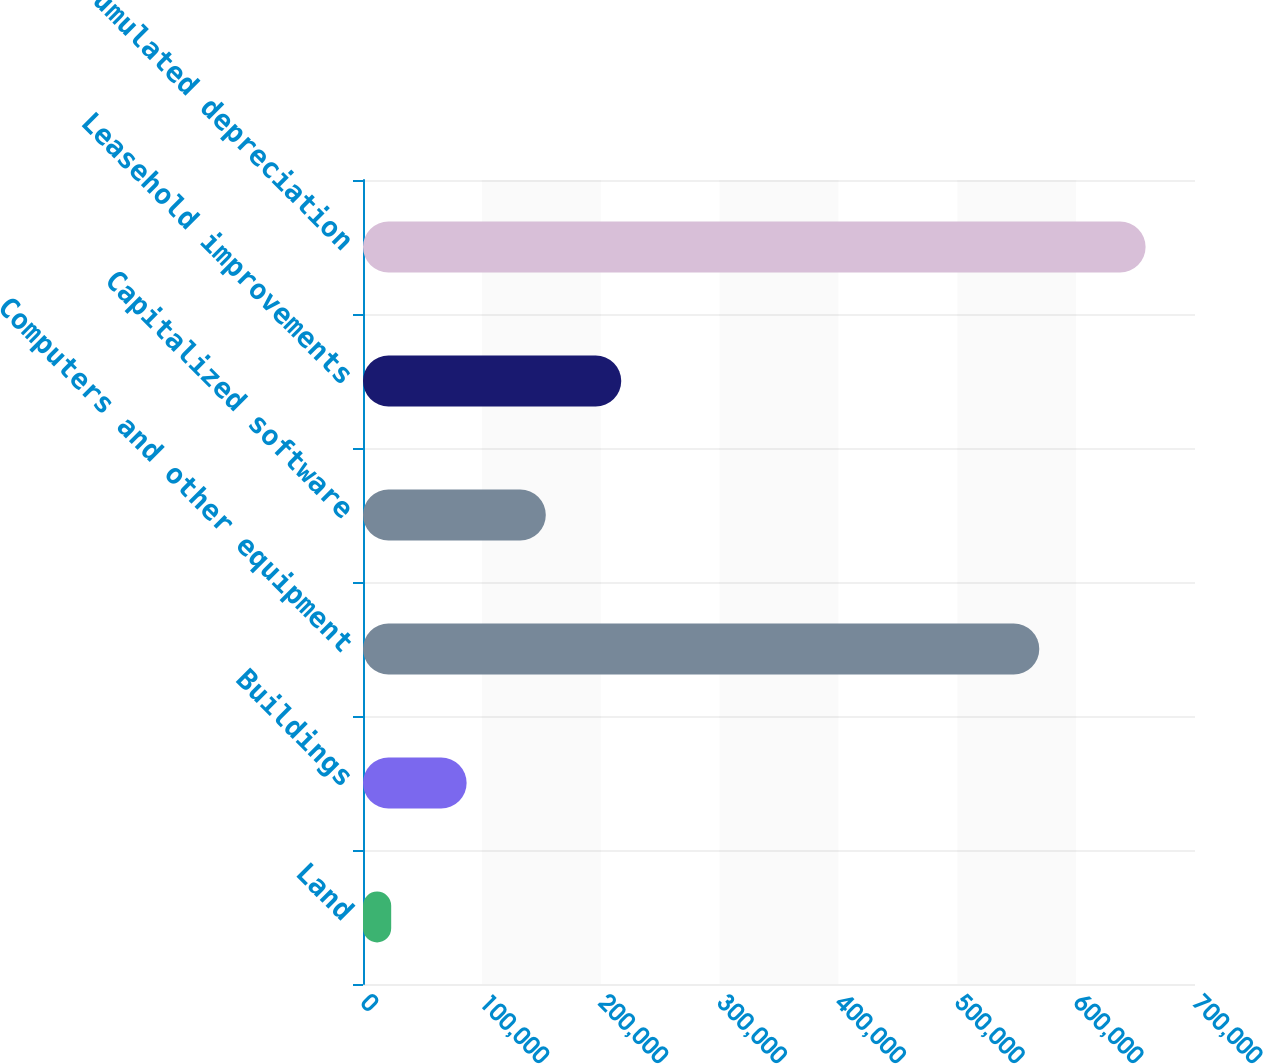Convert chart. <chart><loc_0><loc_0><loc_500><loc_500><bar_chart><fcel>Land<fcel>Buildings<fcel>Computers and other equipment<fcel>Capitalized software<fcel>Leasehold improvements<fcel>Less Accumulated depreciation<nl><fcel>23716<fcel>87186.9<fcel>568986<fcel>153794<fcel>217265<fcel>658425<nl></chart> 